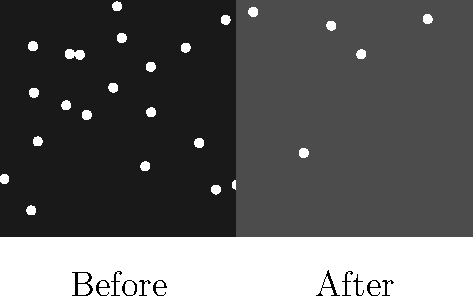As a community police officer collaborating with the security guard, you're tasked with explaining the impact of increased street lighting on star visibility to residents. Using the before-and-after sky images, approximately what percentage of visible stars were lost due to light pollution? To determine the percentage of visible stars lost due to light pollution, we need to follow these steps:

1. Count the number of visible stars in the "Before" image:
   The left half of the image shows approximately 20 visible stars.

2. Count the number of visible stars in the "After" image:
   The right half of the image shows approximately 5 visible stars.

3. Calculate the number of stars lost:
   Stars lost = Stars before - Stars after
   Stars lost = 20 - 5 = 15

4. Calculate the percentage of stars lost:
   Percentage lost = (Stars lost / Stars before) × 100
   Percentage lost = (15 / 20) × 100 = 75%

Therefore, approximately 75% of visible stars were lost due to light pollution.
Answer: 75% 